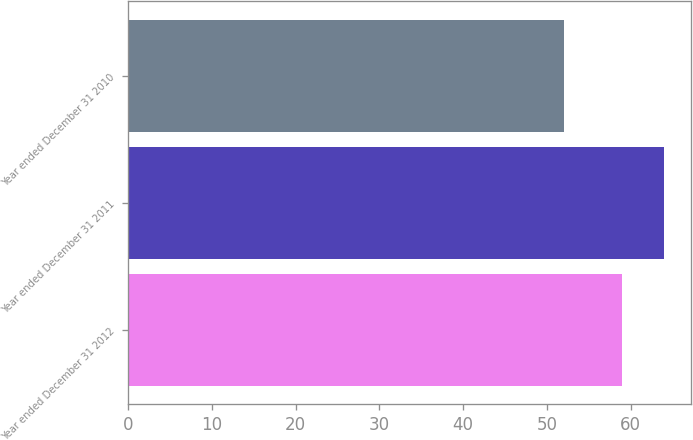Convert chart. <chart><loc_0><loc_0><loc_500><loc_500><bar_chart><fcel>Year ended December 31 2012<fcel>Year ended December 31 2011<fcel>Year ended December 31 2010<nl><fcel>59<fcel>64<fcel>52<nl></chart> 